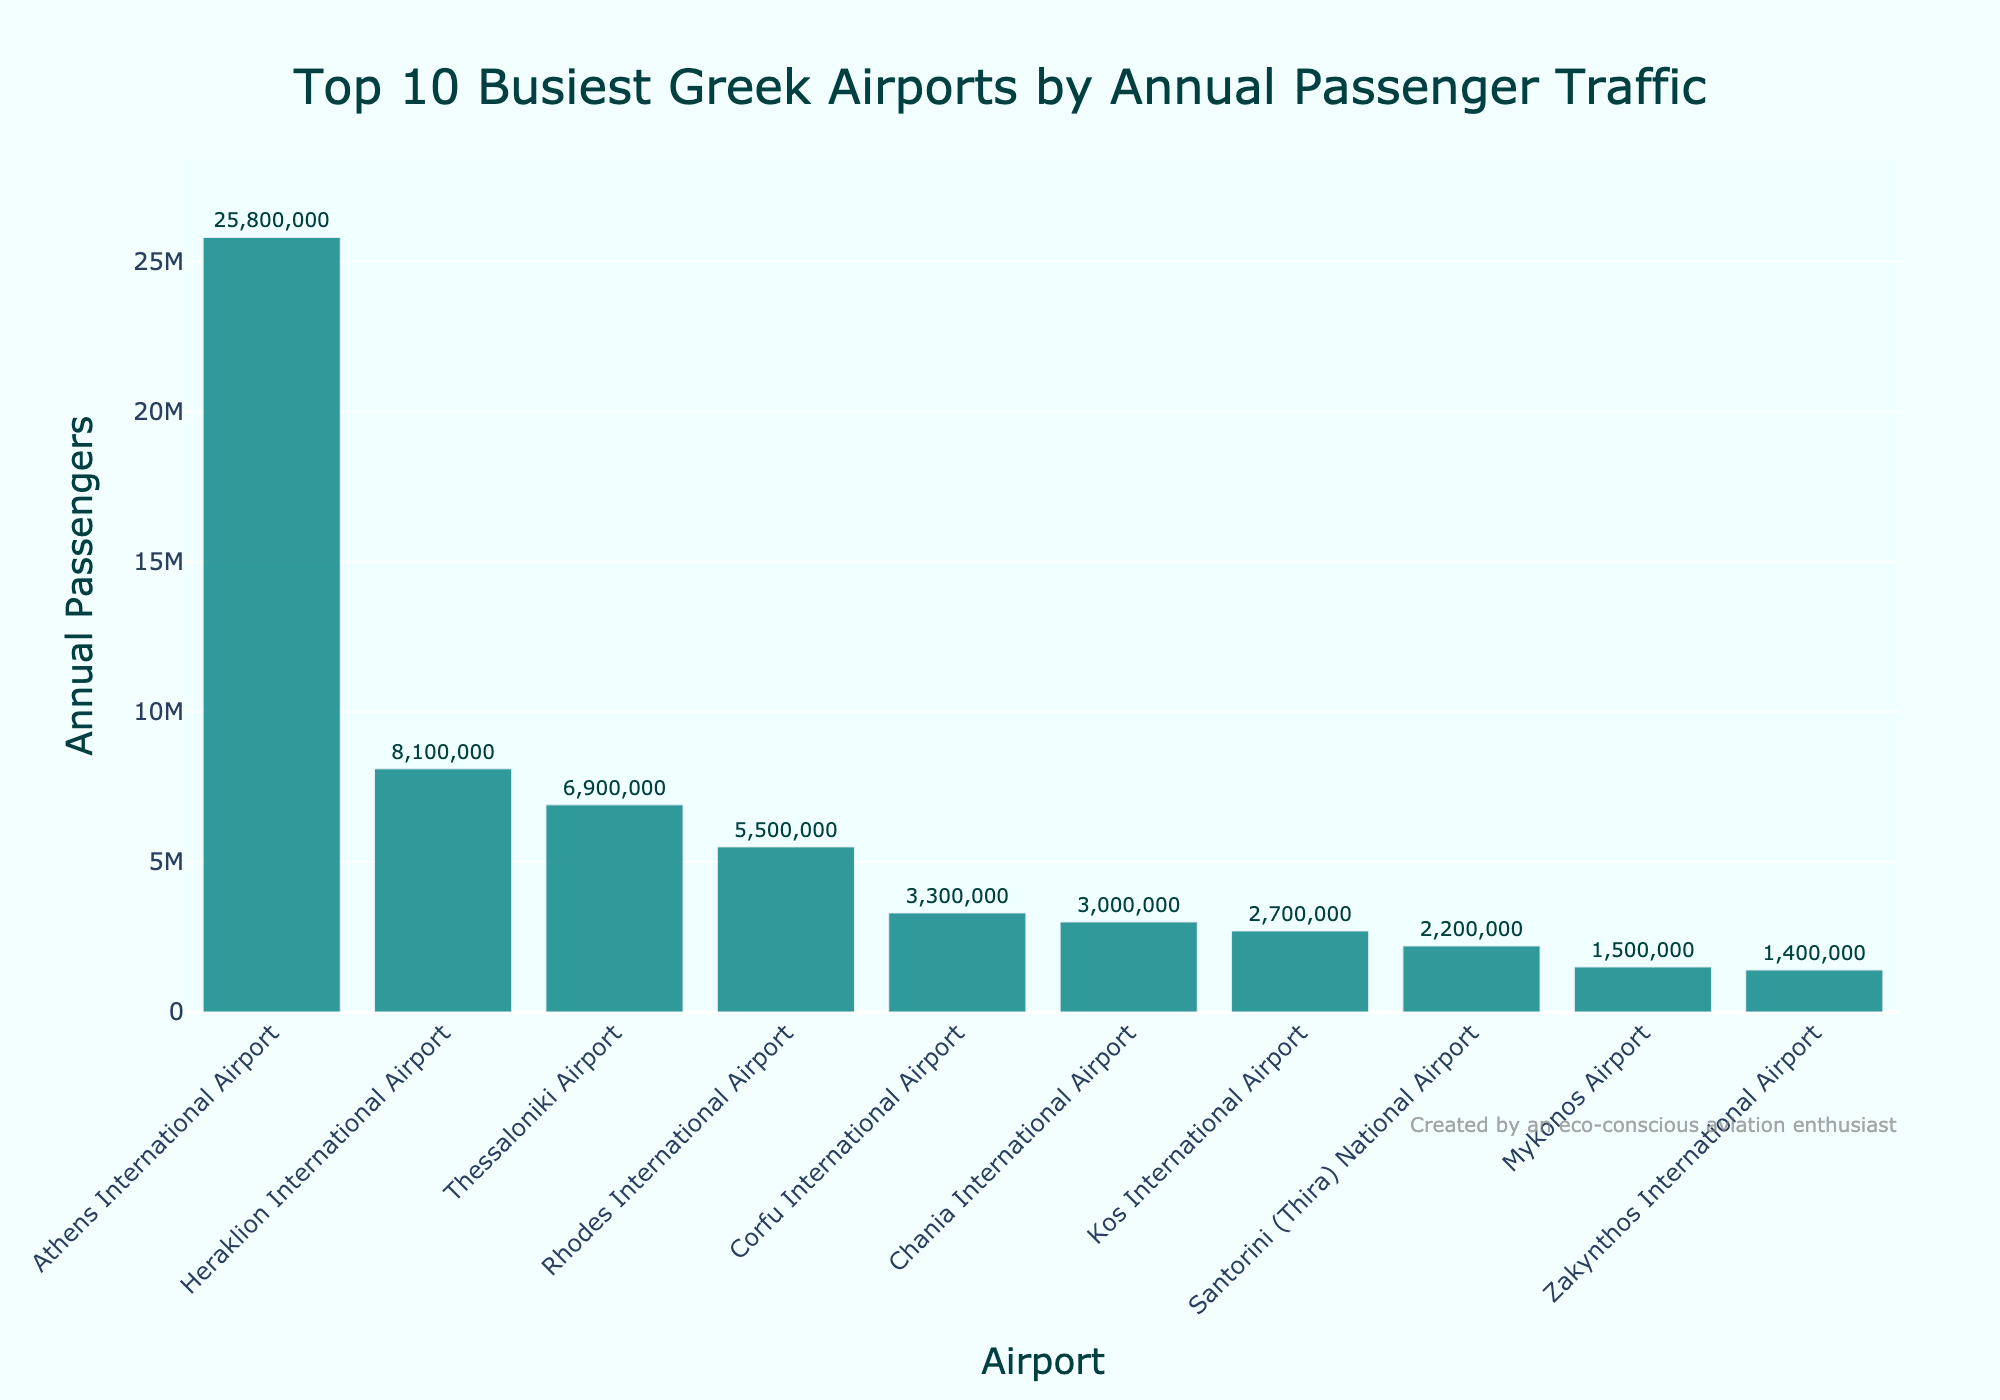What's the busiest Greek airport in terms of annual passenger traffic? The busiest airport will have the tallest bar in the chart. The tallest bar represents Athens International Airport.
Answer: Athens International Airport Which airport has the second highest number of annual passengers? The second tallest bar will indicate the airport with the second highest passenger traffic. The bar for Heraklion International Airport is the second tallest.
Answer: Heraklion International Airport What is the combined annual passenger traffic of the top 3 busiest airports? Sum the annual passengers of the top 3 busiest airports: Athens International Airport (25,800,000) + Heraklion International Airport (8,100,000) + Thessaloniki Airport (6,900,000). The total is 25,800,000 + 8,100,000 + 6,900,000 = 40,800,000.
Answer: 40,800,000 How many passengers does Mykonos Airport handle compared to Santorini Airport? To compare, subtract the number of passengers of Mykonos Airport from Santorini Airport: Santorini (2,200,000) - Mykonos (1,500,000). The difference is 2,200,000 - 1,500,000 = 700,000.
Answer: 700,000 What visual attribute is used to indicate the number of annual passengers? The height of the bars represents the number of annual passengers for each airport. The taller the bar, the higher the number of passengers.
Answer: Height of the bars Which airport has the smallest number of annual passengers among the top 10? The shortest bar represents the airport with the fewest passengers. The shortest bar corresponds to Zakynthos International Airport.
Answer: Zakynthos International Airport If the passenger traffic of Chania International Airport increased by 50%, what would its new total be? Calculate 50% of Chania's current traffic and add it to the original number: 50% of 3,000,000 = 1,500,000; new total = 3,000,000 + 1,500,000 = 4,500,000.
Answer: 4,500,000 What is the average annual passenger traffic of the top 5 busiest airports? Sum the annual passengers of the top 5 airports and divide by 5. Athens (25,800,000) + Heraklion (8,100,000) + Thessaloniki (6,900,000) + Rhodes (5,500,000) + Corfu (3,300,000) = 49,600,000; average = 49,600,000 / 5 = 9,920,000.
Answer: 9,920,000 Which two airports combined have fewer annual passengers than Thessaloniki Airport alone? Identify two airports whose combined total is less than Thessaloniki's 6,900,000: Mykonos (1,500,000) + Zakynthos (1,400,000) = 2,900,000; Santorini (2,200,000) + Zakynthos (1,400,000) = 3,600,000. Both pairs are less than 6,900,000.
Answer: Mykonos and Zakynthos What trend can you observe in terms of annual passenger traffic among the top 10 Greek airports? The bars decrease in height from the busiest to the least busy airport, indicating a descending order of passenger traffic. This trend shows that a few airports dominate in terms of traffic while others handle significantly fewer passengers.
Answer: Decreasing trend 